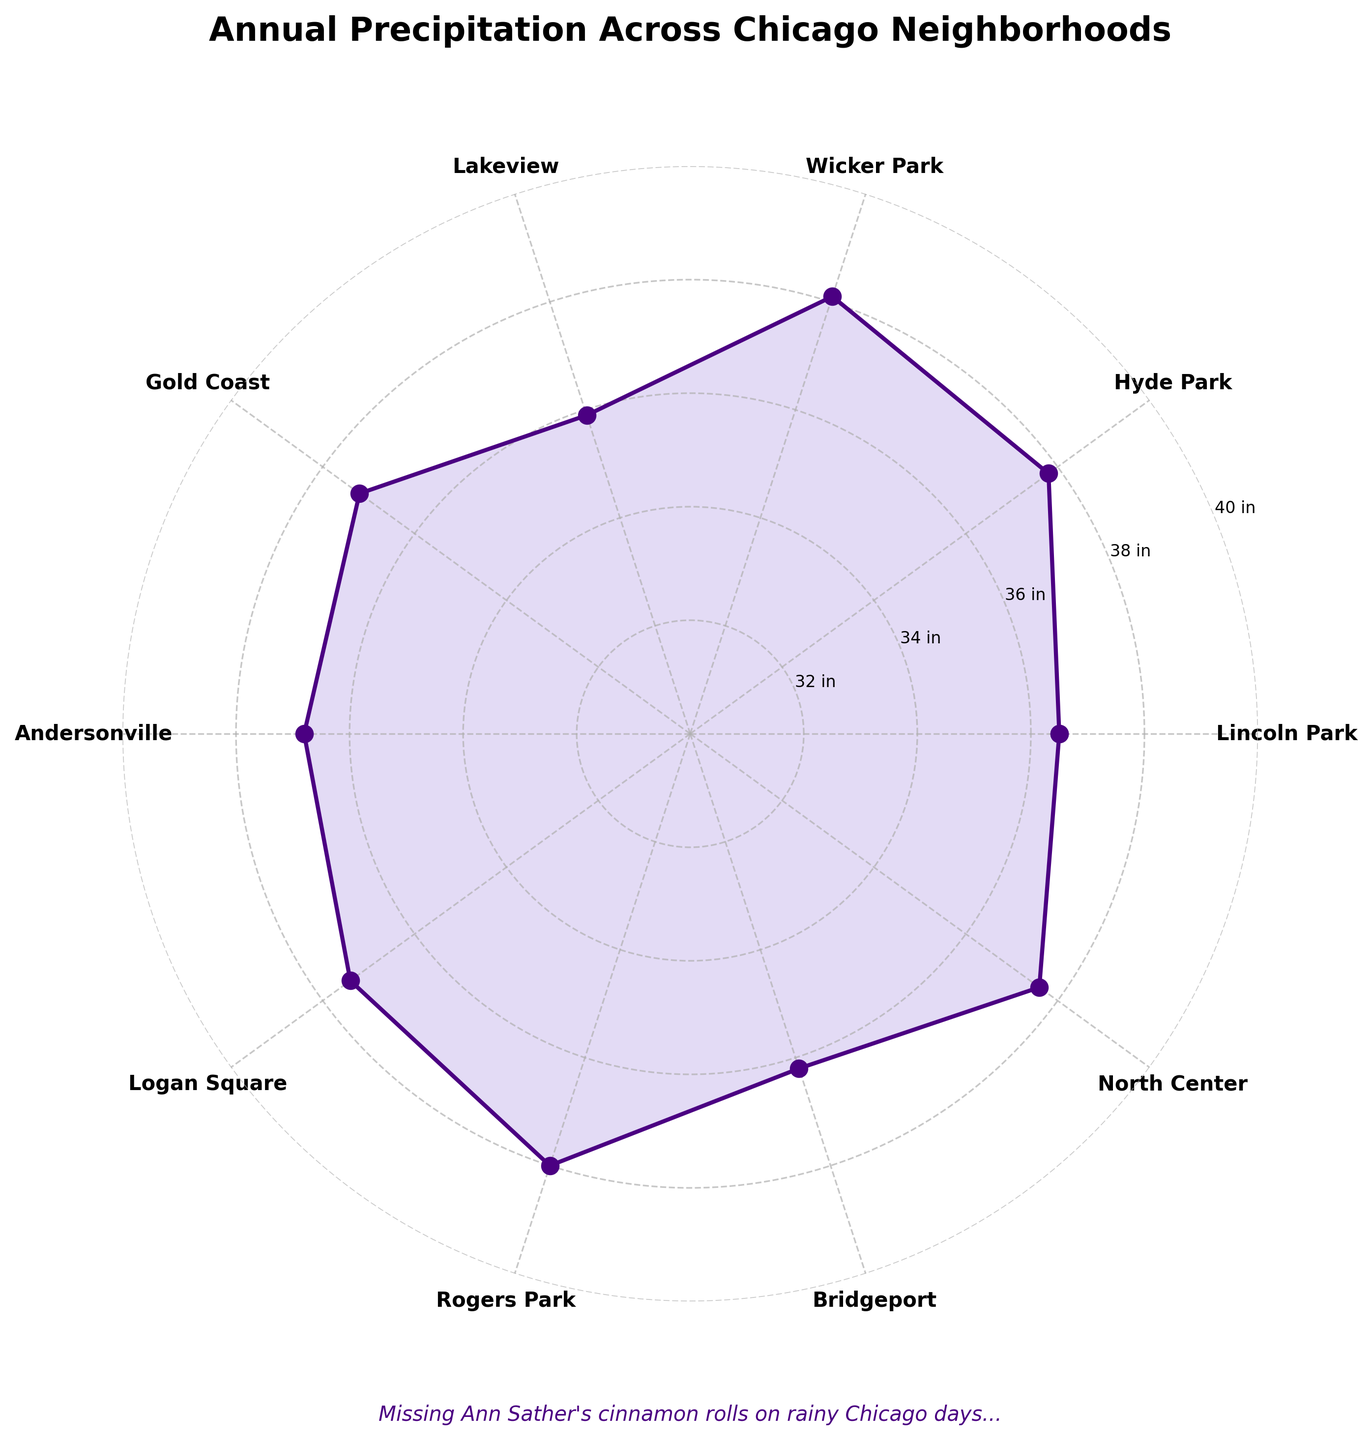what is the title of the plot? The title of the plot is positioned at the top center and it is written in bold font.
Answer: Annual Precipitation Across Chicago Neighborhoods how many neighborhoods are represented on the plot? Each neighborhood is marked around the circle, and by counting the labels, you can determine the number.
Answer: 10 which neighborhood has the highest average annual precipitation? By looking at the outermost point on the radial axis, you can see which neighborhood label it aligns with.
Answer: Wicker Park what is the average annual precipitation for Lincoln Park? Find Lincoln Park's label on the plot and trace the radial line to the value it points to.
Answer: 36.5 inches which neighborhood has less precipitation than Hyde Park but more than Lakeview? Locate Hyde Park and Lakeview on the plot, then find the neighborhood that has a value between their respective values.
Answer: Gold Coast what is the sum of precipitation for Lincoln Park and Bridgeport? Locate each neighborhood on the plot and sum their average annual precipitation values. 36.5 + 36.2 = 72.7
Answer: 72.7 inches which neighborhoods have an average annual precipitation of at least 37 inches? Look for neighborhoods where the radial line intersects the 37 inches mark or higher.
Answer: Gold Coast, Hyde Park, Logan Square, North Center, Rogers Park, Wicker Park what is the overall range of the average annual precipitation shown on the plot? Identify the neighborhood with the highest value and the one with the lowest value, then calculate the difference. 38.1 - 35.9 = 2.2
Answer: 2.2 inches what average annual precipitation value is the most common among the neighborhoods? Review the plot to see which value appears most frequently on the radial lines.
Answer: 37.8 inches how many inches of precipitation separate the neighborhood with the most precipitation from the neighborhood with the least? Subtract the smallest precipitation value from the largest one displayed on the plot. 38.1 - 35.9 = 2.2
Answer: 2.2 inches 